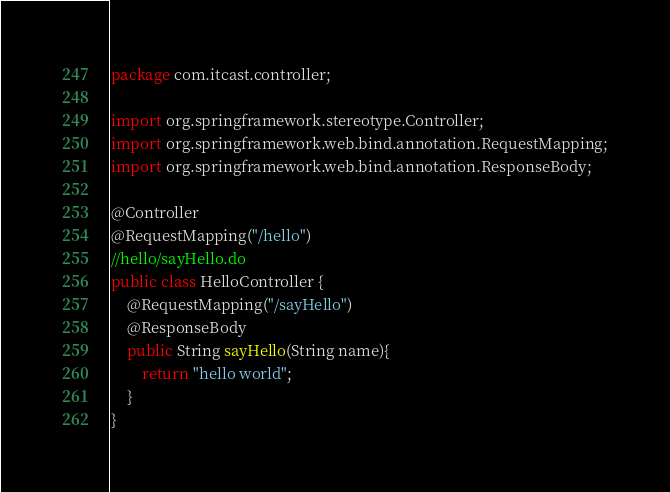<code> <loc_0><loc_0><loc_500><loc_500><_Java_>package com.itcast.controller;

import org.springframework.stereotype.Controller;
import org.springframework.web.bind.annotation.RequestMapping;
import org.springframework.web.bind.annotation.ResponseBody;

@Controller
@RequestMapping("/hello")
//hello/sayHello.do
public class HelloController {
    @RequestMapping("/sayHello")
    @ResponseBody
    public String sayHello(String name){
        return "hello world";
    }
}
</code> 